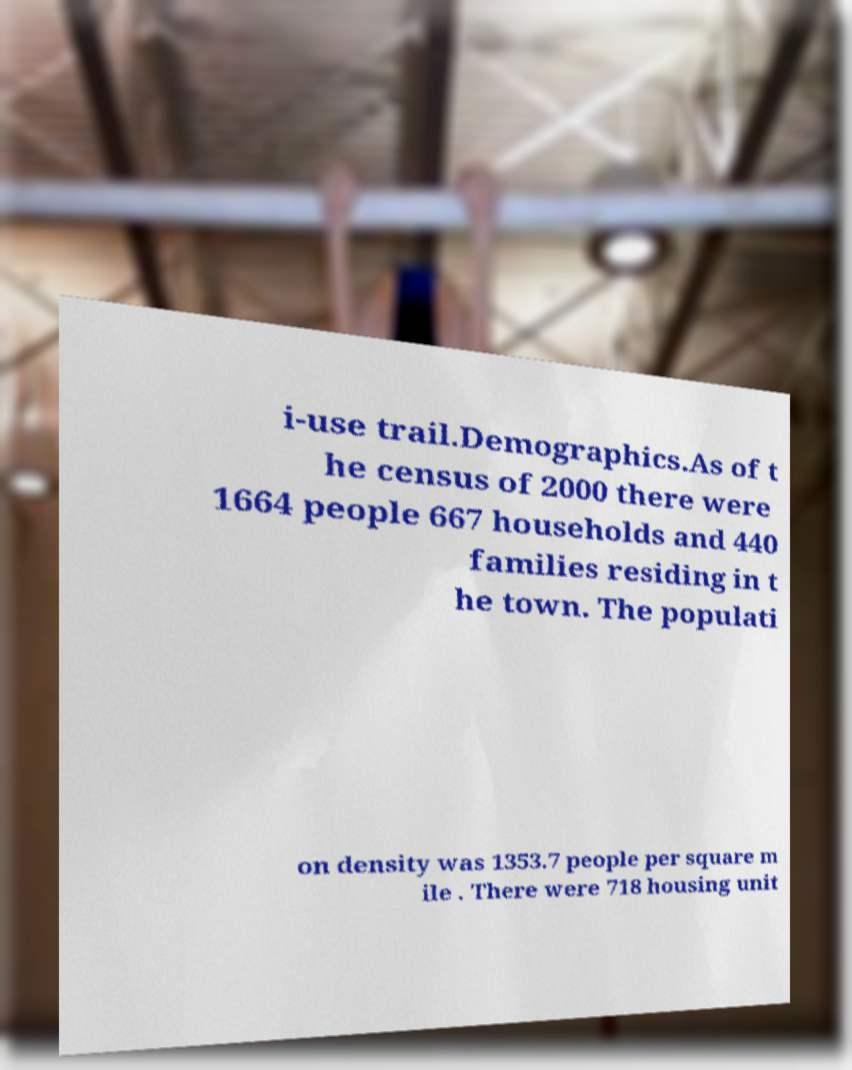There's text embedded in this image that I need extracted. Can you transcribe it verbatim? i-use trail.Demographics.As of t he census of 2000 there were 1664 people 667 households and 440 families residing in t he town. The populati on density was 1353.7 people per square m ile . There were 718 housing unit 